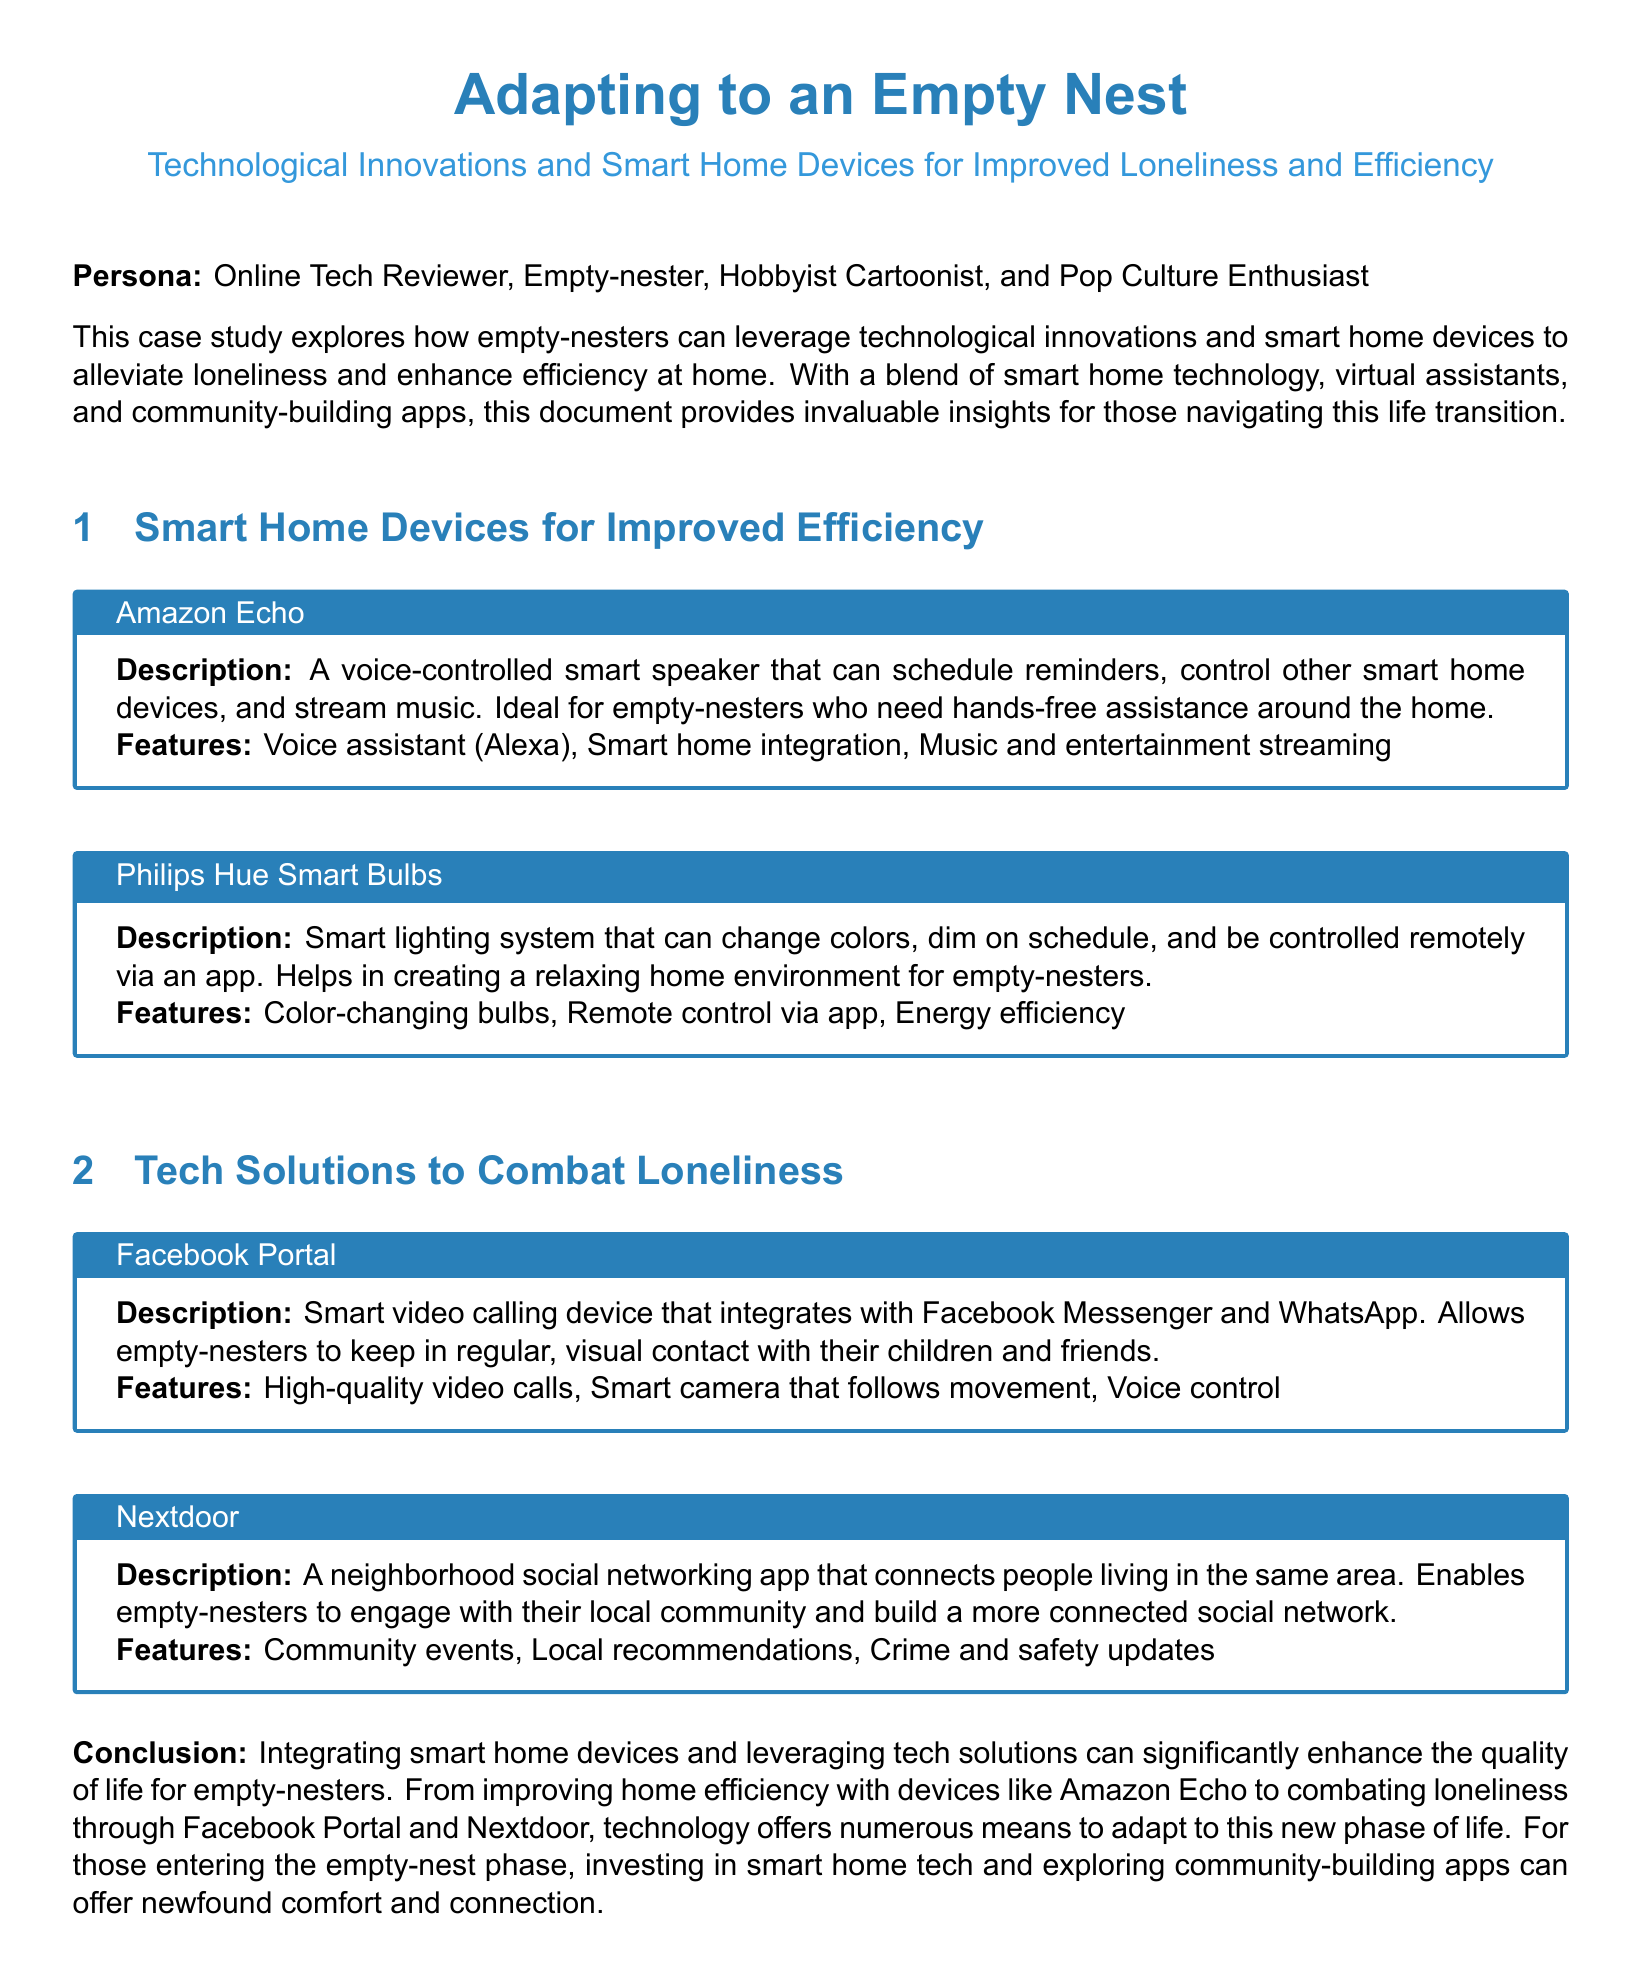What is the title of the case study? The title of the case study is prominently displayed at the beginning, which is "Adapting to an Empty Nest".
Answer: Adapting to an Empty Nest What technology is mentioned for community engagement? The document highlights a neighborhood social networking app as a tech solution to combat loneliness, which is "Nextdoor".
Answer: Nextdoor What device is used for video calling? The case study specifies that "Facebook Portal" is a smart video calling device that helps maintain visual contact.
Answer: Facebook Portal Which smart bulb system is discussed? The study details a lighting product called "Philips Hue Smart Bulbs," focusing on its functionalities.
Answer: Philips Hue Smart Bulbs What feature does the Amazon Echo provide for home assistance? The Amazon Echo offers a voice assistant feature called "Alexa," allowing users to control devices and manage tasks hands-free.
Answer: Voice assistant (Alexa) How can Philips Hue Smart Bulbs enhance living space? The document states that the bulbs can create a relaxing home environment, indicating how they improve ambiance.
Answer: Creating a relaxing home environment What is a benefit of using Nextdoor? The text mentions that Nextdoor helps users engage with local community events and recommendations, reflecting its social utility.
Answer: Community events What is the conclusion about adapting to an empty nest? The conclusion emphasizes that smart home devices and tech solutions significantly enhance the quality of life for empty-nesters.
Answer: Enhance the quality of life for empty-nesters 